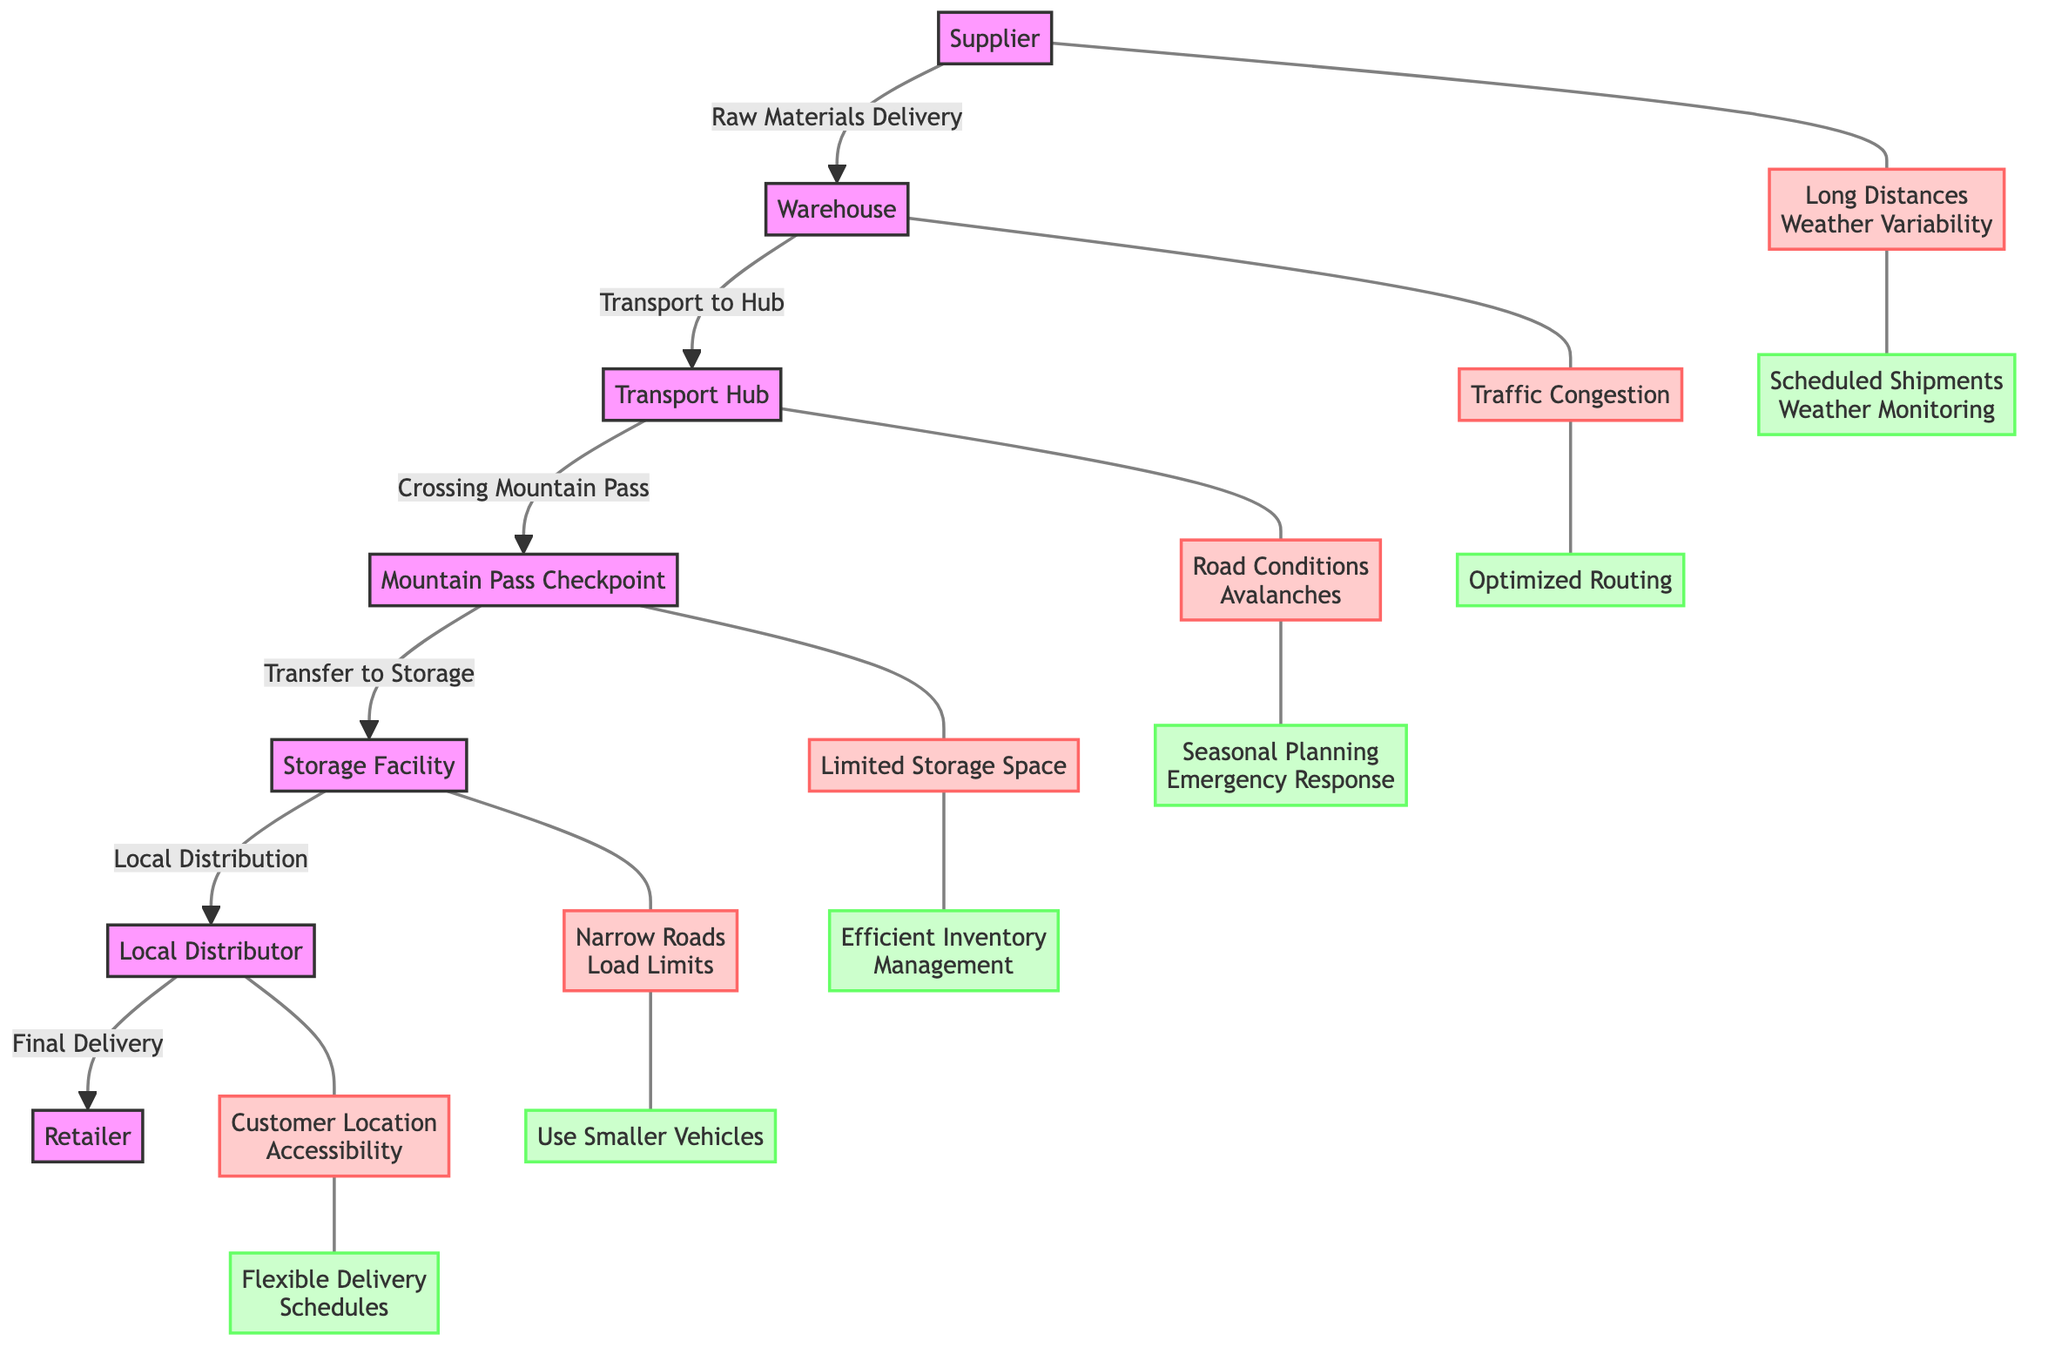What's the first node in the supply chain? The first node listed in the diagram is "Supplier." It is identified at the beginning of the flowchart, indicating the starting point of the supply chain process.
Answer: Supplier How many key challenges are present in the diagram? By reviewing the diagram, there are a total of six key challenges identified, including those related to weather variability, traffic congestion, road conditions, limited storage space, narrow roads, and customer location accessibility.
Answer: 6 What is the final node where goods are delivered? The final node in the supply chain is "Retailer," which is the last step of the delivery process as depicted in the flowchart.
Answer: Retailer What solution addresses long distances and weather variability? The solution that corresponds to the challenge of long distances and weather variability is "Scheduled Shipments and Weather Monitoring," which is explicitly linked to this challenge in the diagram.
Answer: Scheduled Shipments, Weather Monitoring Which challenge is associated with the "Mountain Pass Checkpoint"? The challenge linked to the "Mountain Pass Checkpoint" is "Road Conditions and Avalanches." This information can be gathered by following the flow of connections from the checkpoint to its corresponding challenge node.
Answer: Road Conditions, Avalanches What is a solution for limited storage space? The solution provided for dealing with the challenge of limited storage space is "Efficient Inventory Management." This can be found by tracing the connections from the storage facility to the respective challenge and solution nodes.
Answer: Efficient Inventory Management How many nodes represent challenges in the flowchart? The flowchart contains six nodes that represent challenges, which can be counted by identifying all the challenge nodes in the diagram.
Answer: 6 Which node follows the "Storage Facility"? The node that follows the "Storage Facility" in the flowchart is the "Local Distributor." You can determine this by noting the direction of the arrows leading from the storage facility to the next node.
Answer: Local Distributor What is the corresponding solution for 'Narrow Roads and Load Limits'? The solution listed for the challenge of 'Narrow Roads and Load Limits' is "Use Smaller Vehicles." This link can be confirmed by following the connections from the challenge to its corresponding solution node.
Answer: Use Smaller Vehicles 